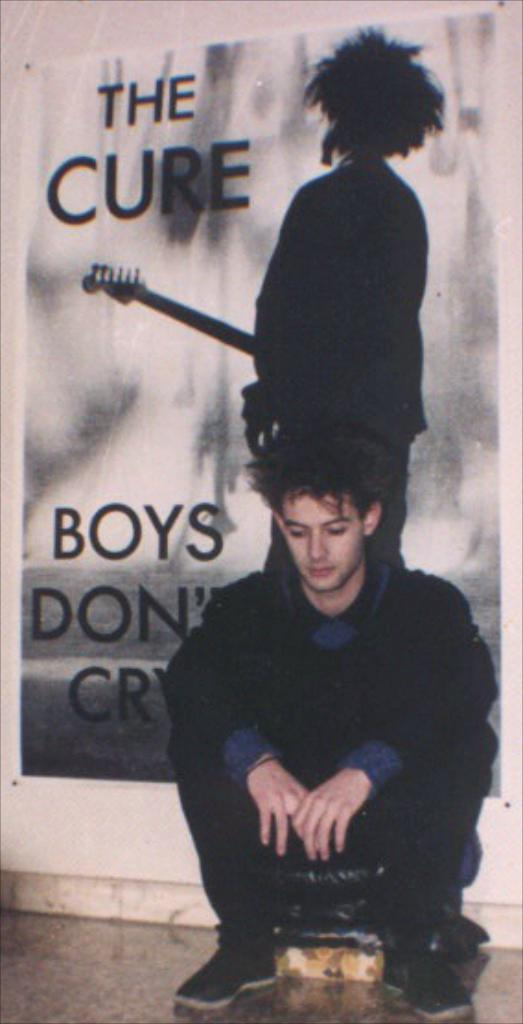What is the main subject of the image? There is a person sitting in the image. What else can be seen in the image besides the person? There is a board with a picture of a person and text on it. Where is the board located in the image? The board is pinned on a wall. Can you tell me how many jellyfish are swimming in the image? There are no jellyfish present in the image; it features a person sitting and a board with a picture and text. 